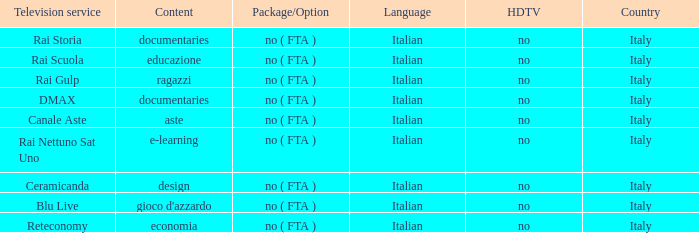What is the high-definition tv for the rai nettuno sat uno television service? No. 